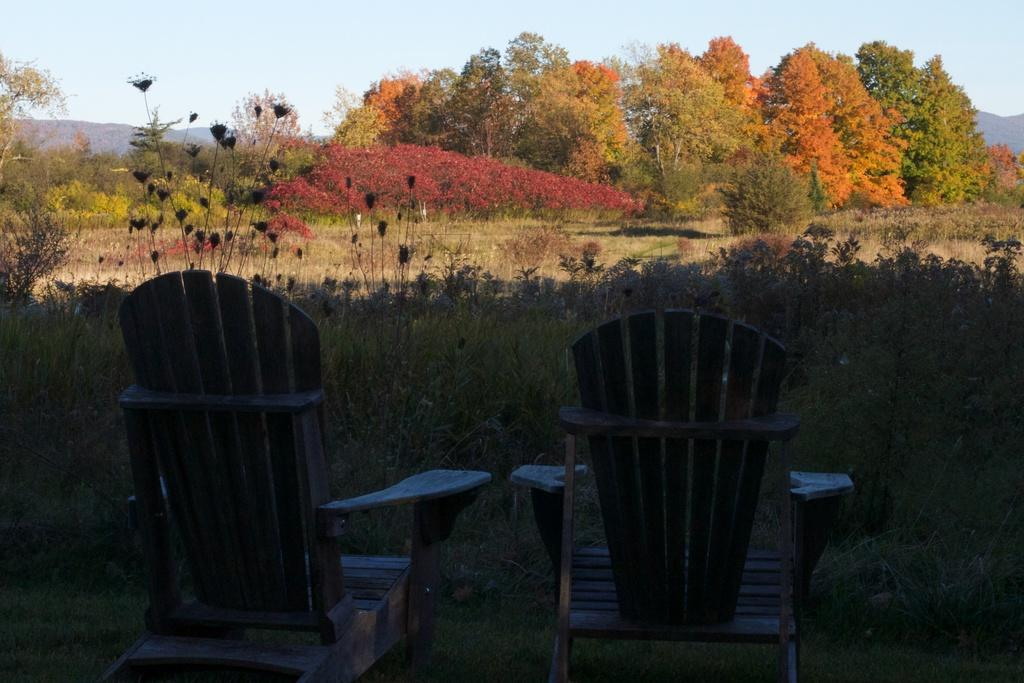What type of furniture is present in the image? There are two wooden chairs in the image. What can be seen in the background of the image? There are many trees in the background of the image. What is visible at the top of the image? The sky is visible at the top of the image. What type of ground surface is in front of the chairs? There is grass in front of the chairs. Can you see a woman rolling on the grass in the image? There is no woman rolling on the grass in the image. Is there any ice visible in the image? There is no ice present in the image. 